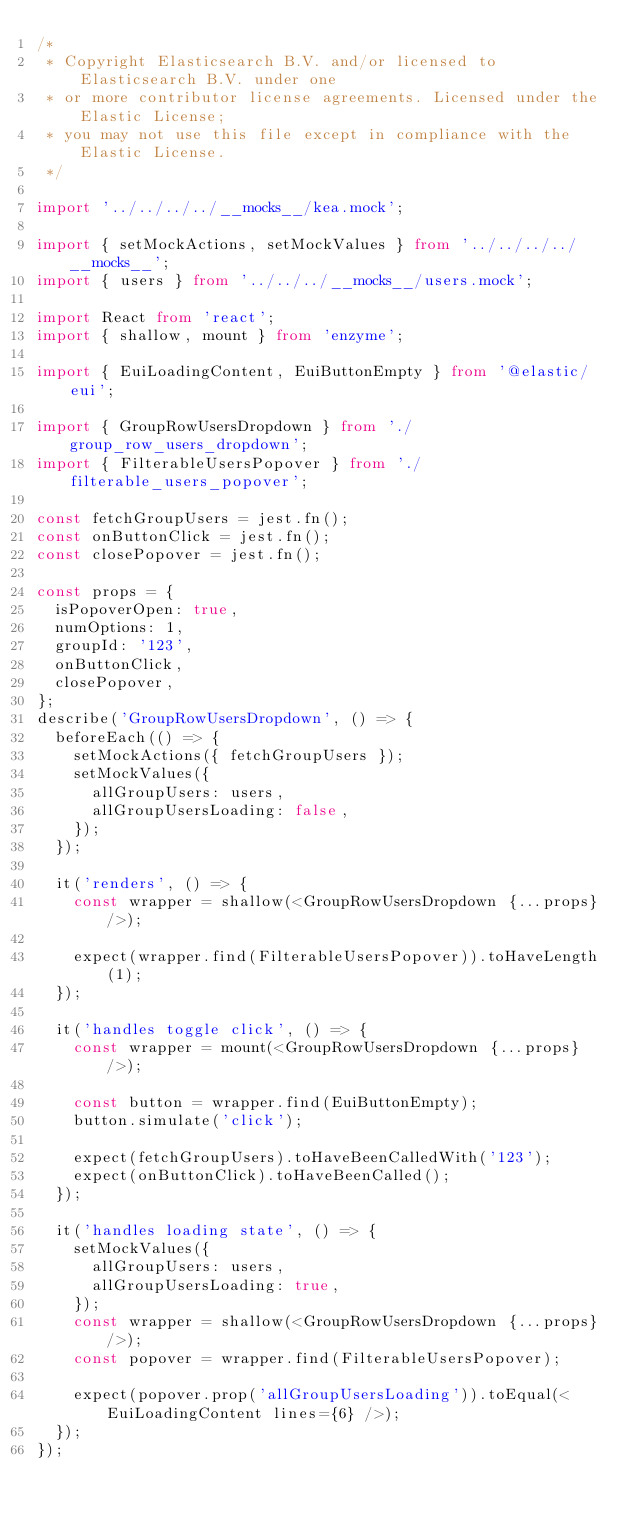Convert code to text. <code><loc_0><loc_0><loc_500><loc_500><_TypeScript_>/*
 * Copyright Elasticsearch B.V. and/or licensed to Elasticsearch B.V. under one
 * or more contributor license agreements. Licensed under the Elastic License;
 * you may not use this file except in compliance with the Elastic License.
 */

import '../../../../__mocks__/kea.mock';

import { setMockActions, setMockValues } from '../../../../__mocks__';
import { users } from '../../../__mocks__/users.mock';

import React from 'react';
import { shallow, mount } from 'enzyme';

import { EuiLoadingContent, EuiButtonEmpty } from '@elastic/eui';

import { GroupRowUsersDropdown } from './group_row_users_dropdown';
import { FilterableUsersPopover } from './filterable_users_popover';

const fetchGroupUsers = jest.fn();
const onButtonClick = jest.fn();
const closePopover = jest.fn();

const props = {
  isPopoverOpen: true,
  numOptions: 1,
  groupId: '123',
  onButtonClick,
  closePopover,
};
describe('GroupRowUsersDropdown', () => {
  beforeEach(() => {
    setMockActions({ fetchGroupUsers });
    setMockValues({
      allGroupUsers: users,
      allGroupUsersLoading: false,
    });
  });

  it('renders', () => {
    const wrapper = shallow(<GroupRowUsersDropdown {...props} />);

    expect(wrapper.find(FilterableUsersPopover)).toHaveLength(1);
  });

  it('handles toggle click', () => {
    const wrapper = mount(<GroupRowUsersDropdown {...props} />);

    const button = wrapper.find(EuiButtonEmpty);
    button.simulate('click');

    expect(fetchGroupUsers).toHaveBeenCalledWith('123');
    expect(onButtonClick).toHaveBeenCalled();
  });

  it('handles loading state', () => {
    setMockValues({
      allGroupUsers: users,
      allGroupUsersLoading: true,
    });
    const wrapper = shallow(<GroupRowUsersDropdown {...props} />);
    const popover = wrapper.find(FilterableUsersPopover);

    expect(popover.prop('allGroupUsersLoading')).toEqual(<EuiLoadingContent lines={6} />);
  });
});
</code> 